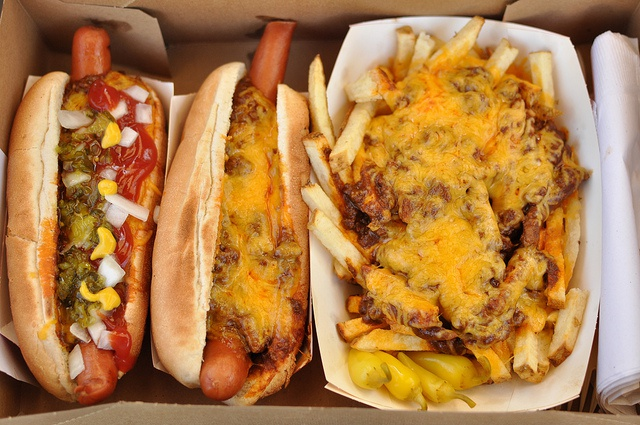Describe the objects in this image and their specific colors. I can see hot dog in maroon, tan, red, and orange tones, hot dog in maroon, brown, and tan tones, and carrot in maroon, brown, and red tones in this image. 